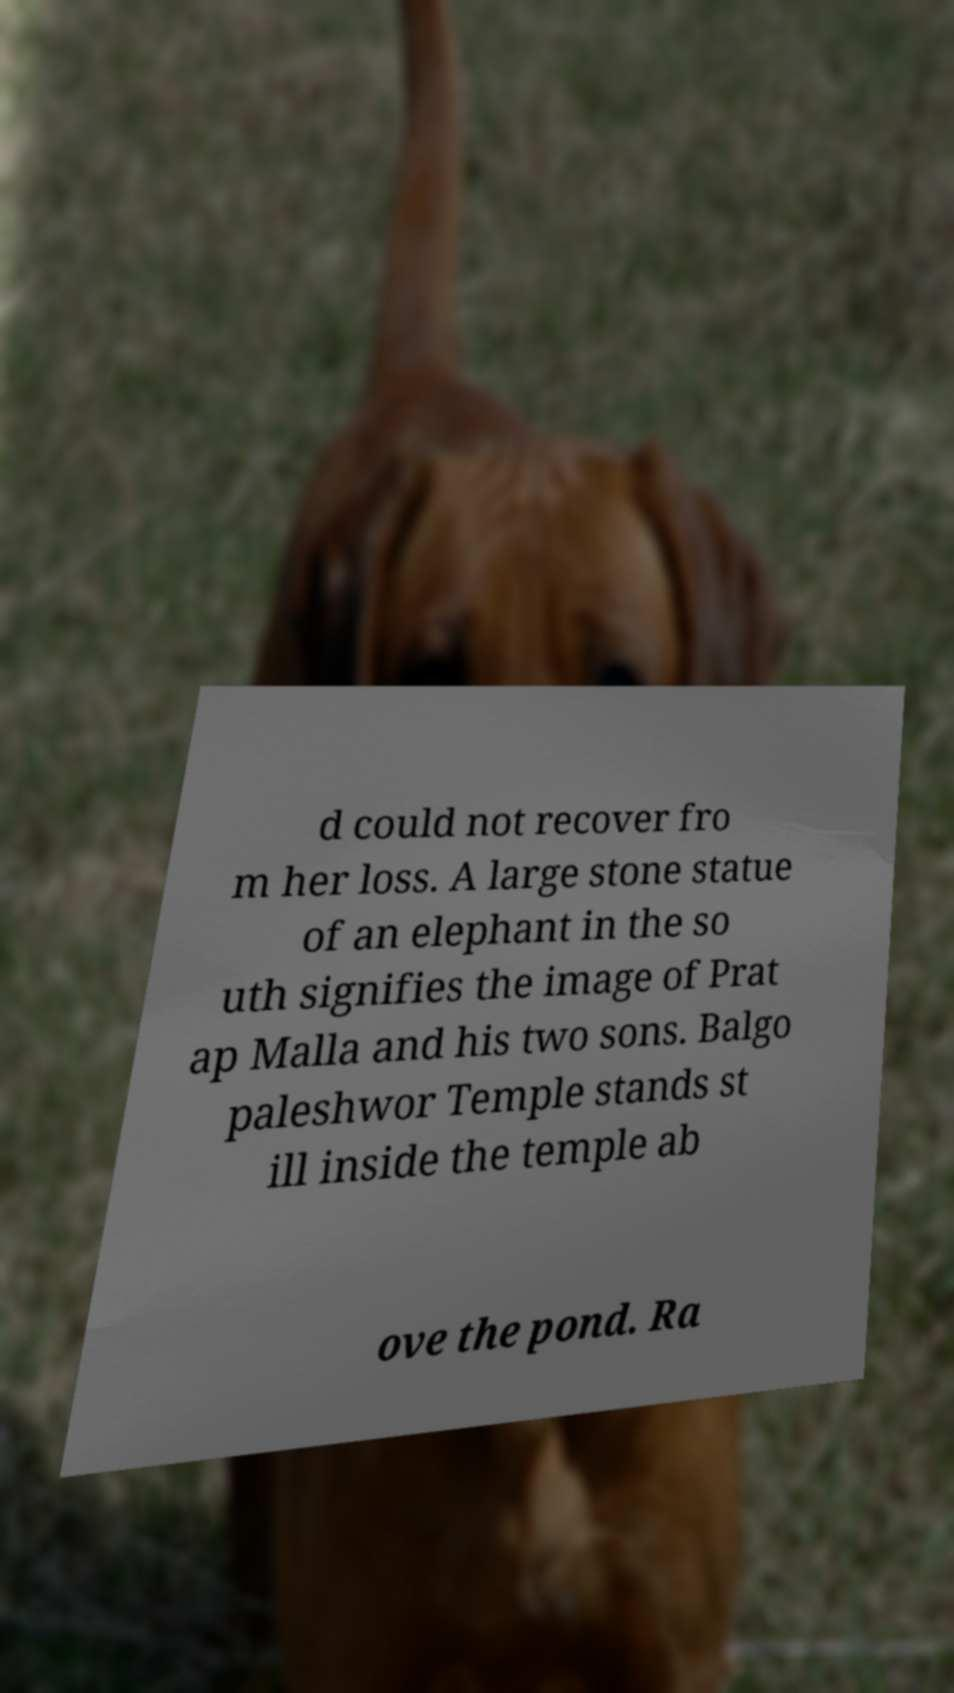Please identify and transcribe the text found in this image. d could not recover fro m her loss. A large stone statue of an elephant in the so uth signifies the image of Prat ap Malla and his two sons. Balgo paleshwor Temple stands st ill inside the temple ab ove the pond. Ra 